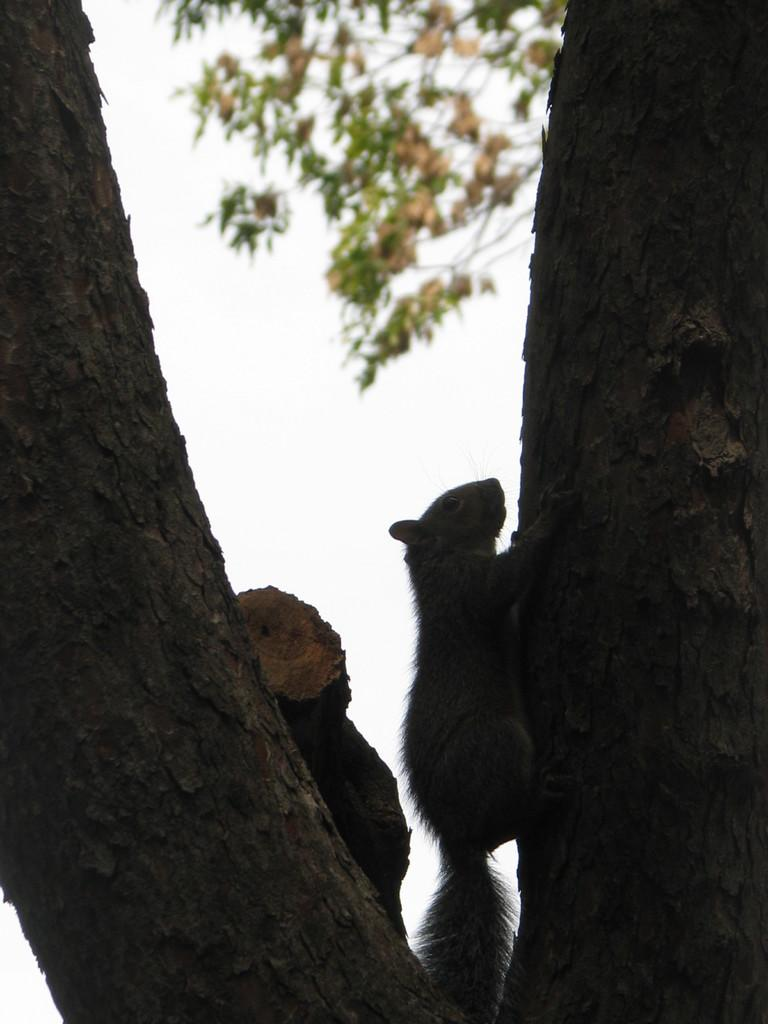What animal can be seen in the image? There is a squirrel in the image. What is the squirrel doing in the image? The squirrel is climbing a tree. What can be seen in the background of the image? The sky is visible in the background of the image. What type of silk is being used by the squirrel to climb the tree in the image? There is no silk present in the image, and the squirrel is climbing the tree using its claws and tail. 